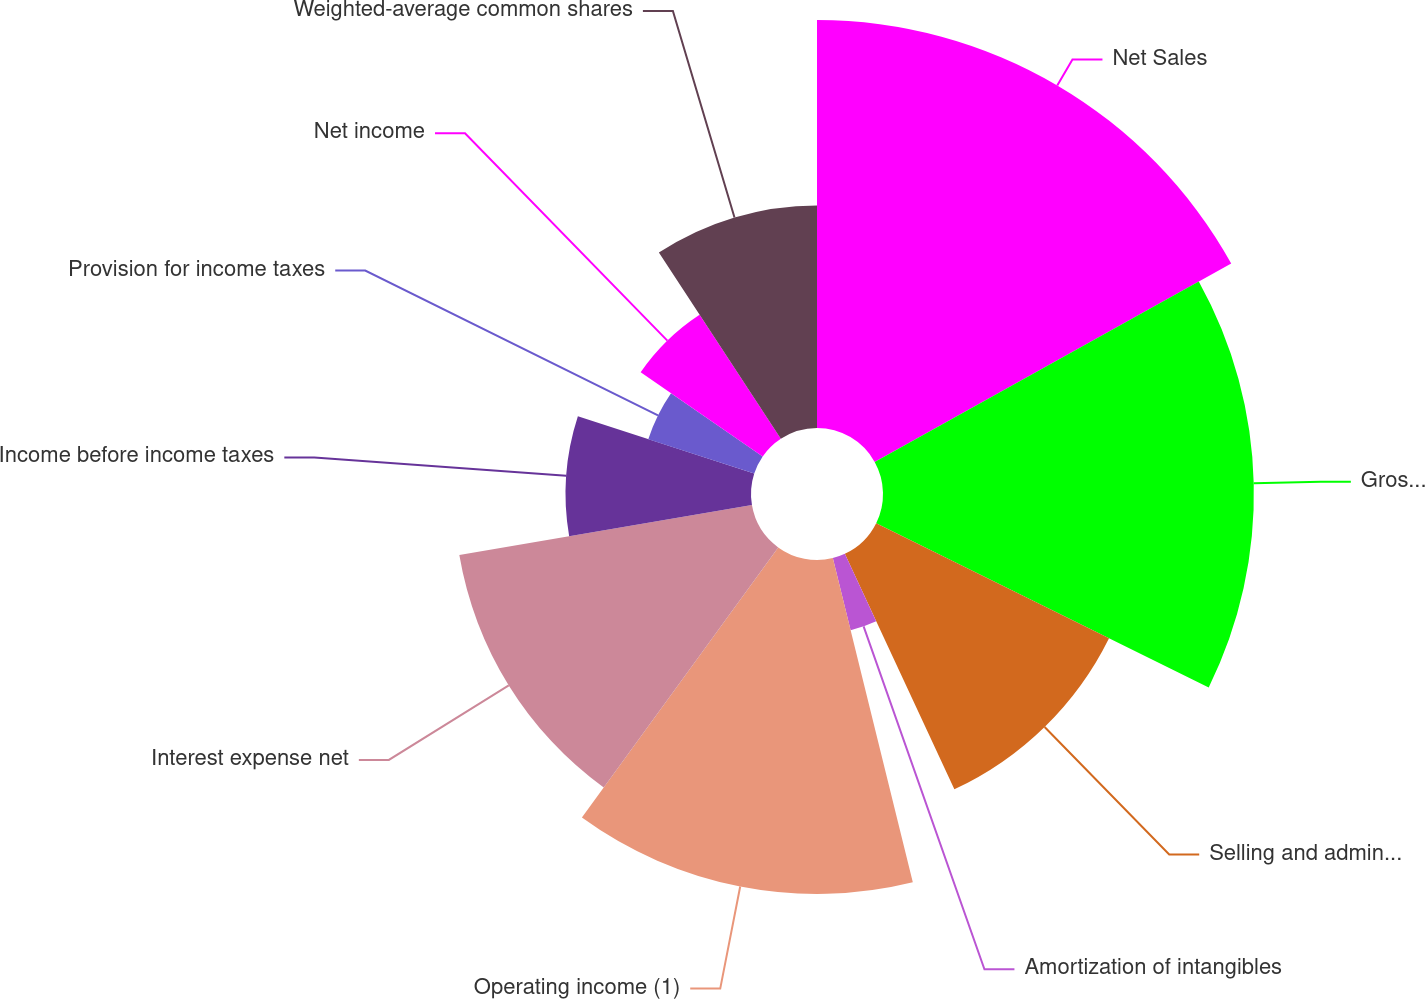Convert chart to OTSL. <chart><loc_0><loc_0><loc_500><loc_500><pie_chart><fcel>Net Sales<fcel>Gross profit (1)<fcel>Selling and administrative<fcel>Amortization of intangibles<fcel>Operating income (1)<fcel>Interest expense net<fcel>Income before income taxes<fcel>Provision for income taxes<fcel>Net income<fcel>Weighted-average common shares<nl><fcel>16.92%<fcel>15.38%<fcel>10.77%<fcel>3.08%<fcel>13.85%<fcel>12.31%<fcel>7.69%<fcel>4.62%<fcel>6.15%<fcel>9.23%<nl></chart> 